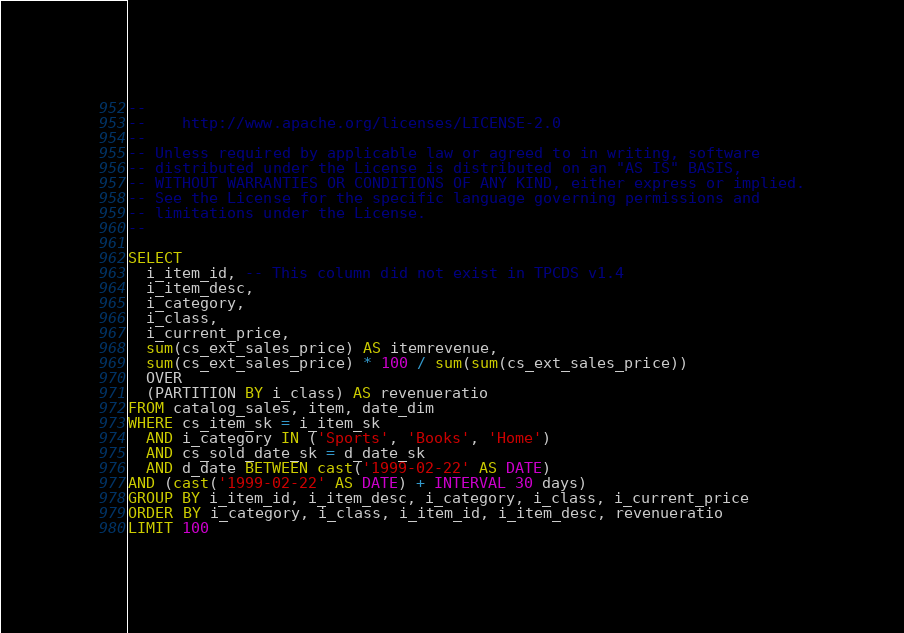Convert code to text. <code><loc_0><loc_0><loc_500><loc_500><_SQL_>--
--    http://www.apache.org/licenses/LICENSE-2.0
--
-- Unless required by applicable law or agreed to in writing, software
-- distributed under the License is distributed on an "AS IS" BASIS,
-- WITHOUT WARRANTIES OR CONDITIONS OF ANY KIND, either express or implied.
-- See the License for the specific language governing permissions and
-- limitations under the License.
--

SELECT
  i_item_id, -- This column did not exist in TPCDS v1.4
  i_item_desc,
  i_category,
  i_class,
  i_current_price,
  sum(cs_ext_sales_price) AS itemrevenue,
  sum(cs_ext_sales_price) * 100 / sum(sum(cs_ext_sales_price))
  OVER
  (PARTITION BY i_class) AS revenueratio
FROM catalog_sales, item, date_dim
WHERE cs_item_sk = i_item_sk
  AND i_category IN ('Sports', 'Books', 'Home')
  AND cs_sold_date_sk = d_date_sk
  AND d_date BETWEEN cast('1999-02-22' AS DATE)
AND (cast('1999-02-22' AS DATE) + INTERVAL 30 days)
GROUP BY i_item_id, i_item_desc, i_category, i_class, i_current_price
ORDER BY i_category, i_class, i_item_id, i_item_desc, revenueratio
LIMIT 100
</code> 